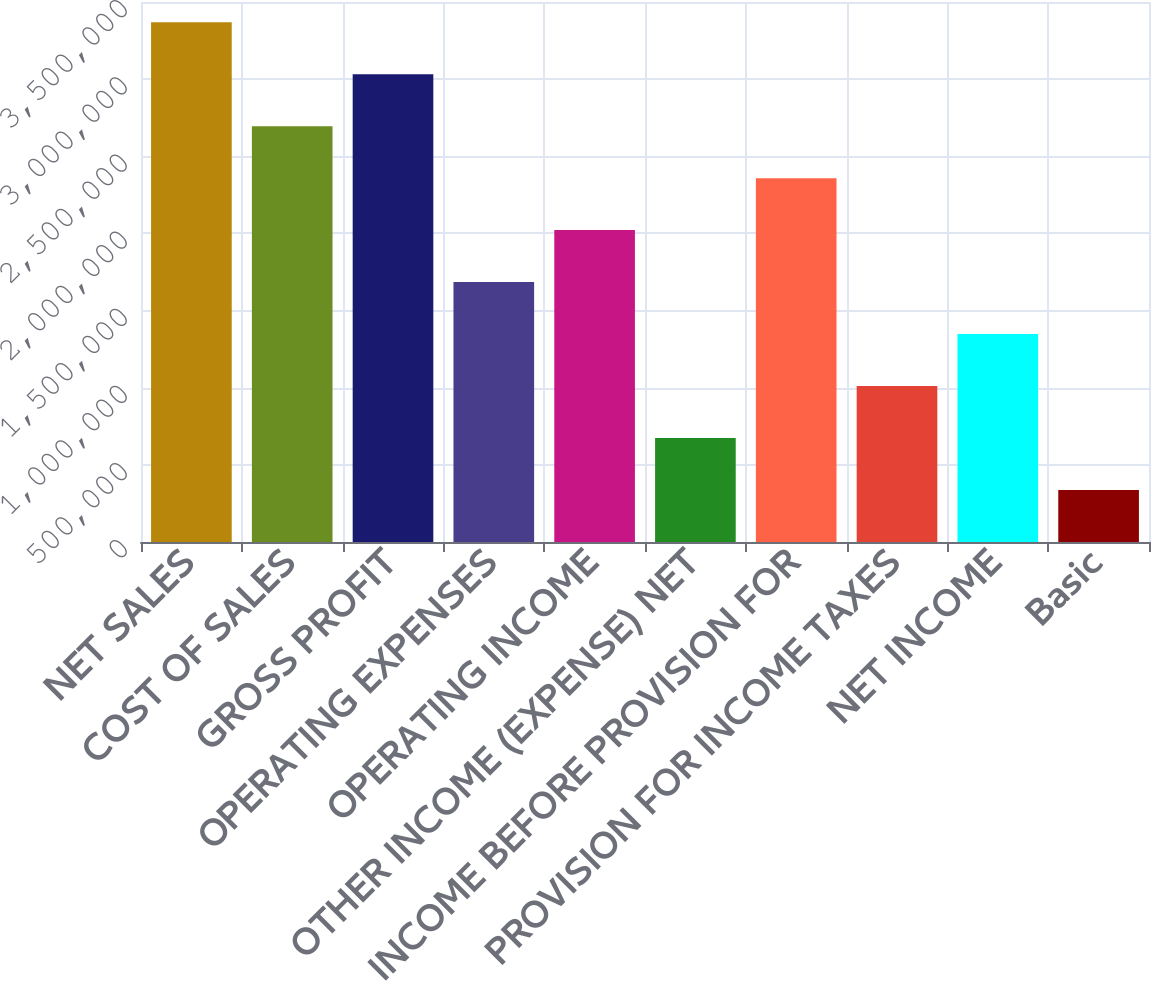Convert chart. <chart><loc_0><loc_0><loc_500><loc_500><bar_chart><fcel>NET SALES<fcel>COST OF SALES<fcel>GROSS PROFIT<fcel>OPERATING EXPENSES<fcel>OPERATING INCOME<fcel>OTHER INCOME (EXPENSE) NET<fcel>INCOME BEFORE PROVISION FOR<fcel>PROVISION FOR INCOME TAXES<fcel>NET INCOME<fcel>Basic<nl><fcel>3.36905e+06<fcel>2.69524e+06<fcel>3.03214e+06<fcel>1.68452e+06<fcel>2.02143e+06<fcel>673810<fcel>2.35833e+06<fcel>1.01071e+06<fcel>1.34762e+06<fcel>336906<nl></chart> 